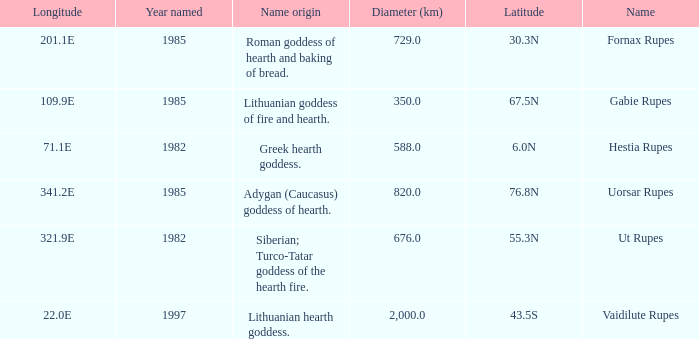At a longitude of 109.9e, how many features were found? 1.0. 